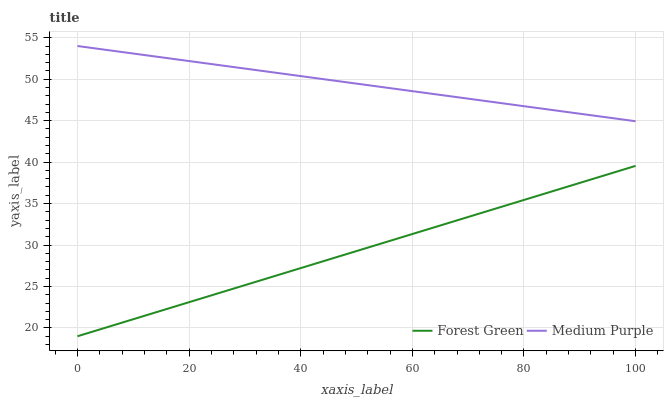Does Forest Green have the minimum area under the curve?
Answer yes or no. Yes. Does Medium Purple have the maximum area under the curve?
Answer yes or no. Yes. Does Forest Green have the maximum area under the curve?
Answer yes or no. No. Is Medium Purple the smoothest?
Answer yes or no. Yes. Is Forest Green the roughest?
Answer yes or no. Yes. Is Forest Green the smoothest?
Answer yes or no. No. Does Forest Green have the lowest value?
Answer yes or no. Yes. Does Medium Purple have the highest value?
Answer yes or no. Yes. Does Forest Green have the highest value?
Answer yes or no. No. Is Forest Green less than Medium Purple?
Answer yes or no. Yes. Is Medium Purple greater than Forest Green?
Answer yes or no. Yes. Does Forest Green intersect Medium Purple?
Answer yes or no. No. 